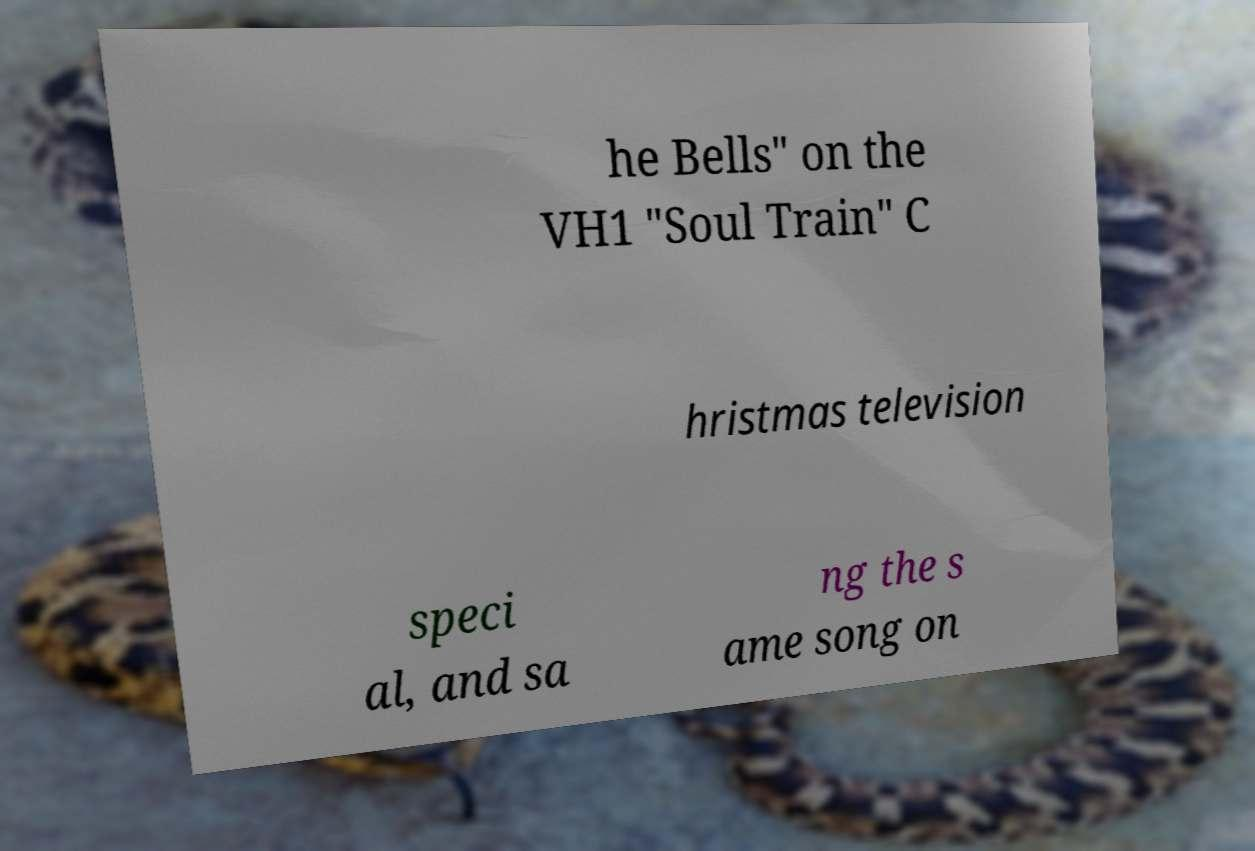There's text embedded in this image that I need extracted. Can you transcribe it verbatim? he Bells" on the VH1 "Soul Train" C hristmas television speci al, and sa ng the s ame song on 